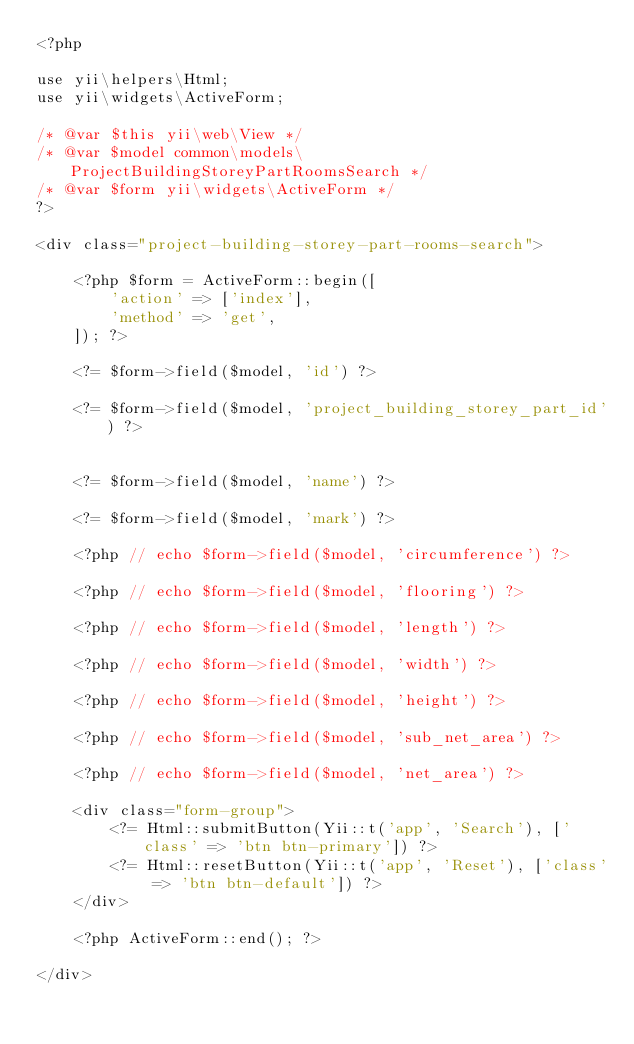Convert code to text. <code><loc_0><loc_0><loc_500><loc_500><_PHP_><?php

use yii\helpers\Html;
use yii\widgets\ActiveForm;

/* @var $this yii\web\View */
/* @var $model common\models\ProjectBuildingStoreyPartRoomsSearch */
/* @var $form yii\widgets\ActiveForm */
?>

<div class="project-building-storey-part-rooms-search">

    <?php $form = ActiveForm::begin([
        'action' => ['index'],
        'method' => 'get',
    ]); ?>

    <?= $form->field($model, 'id') ?>

    <?= $form->field($model, 'project_building_storey_part_id') ?>


    <?= $form->field($model, 'name') ?>

    <?= $form->field($model, 'mark') ?>

    <?php // echo $form->field($model, 'circumference') ?>

    <?php // echo $form->field($model, 'flooring') ?>

    <?php // echo $form->field($model, 'length') ?>

    <?php // echo $form->field($model, 'width') ?>

    <?php // echo $form->field($model, 'height') ?>

    <?php // echo $form->field($model, 'sub_net_area') ?>

    <?php // echo $form->field($model, 'net_area') ?>

    <div class="form-group">
        <?= Html::submitButton(Yii::t('app', 'Search'), ['class' => 'btn btn-primary']) ?>
        <?= Html::resetButton(Yii::t('app', 'Reset'), ['class' => 'btn btn-default']) ?>
    </div>

    <?php ActiveForm::end(); ?>

</div>
</code> 